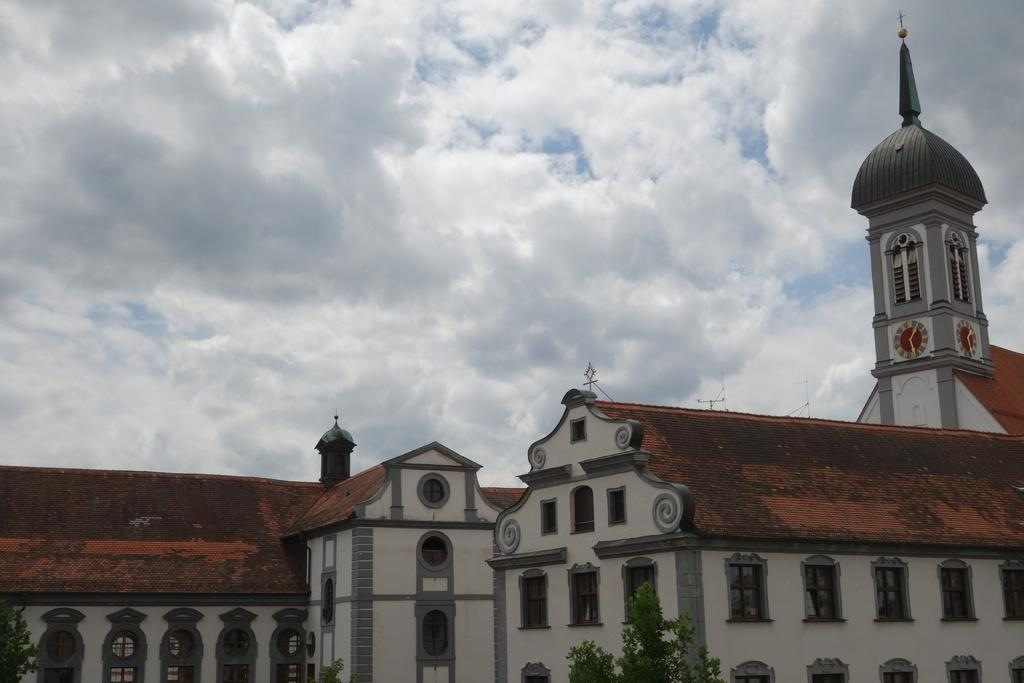What type of structures can be seen in the image? There are buildings in the image. What other natural elements are present in the image? There are trees in the image. What is visible in the background of the image? The sky is visible in the image. Can you describe the sky in the image? Clouds are present in the sky. Where is the cave located in the image? There is no cave present in the image. What type of spark can be seen coming from the truck in the image? There is no truck or spark present in the image. 